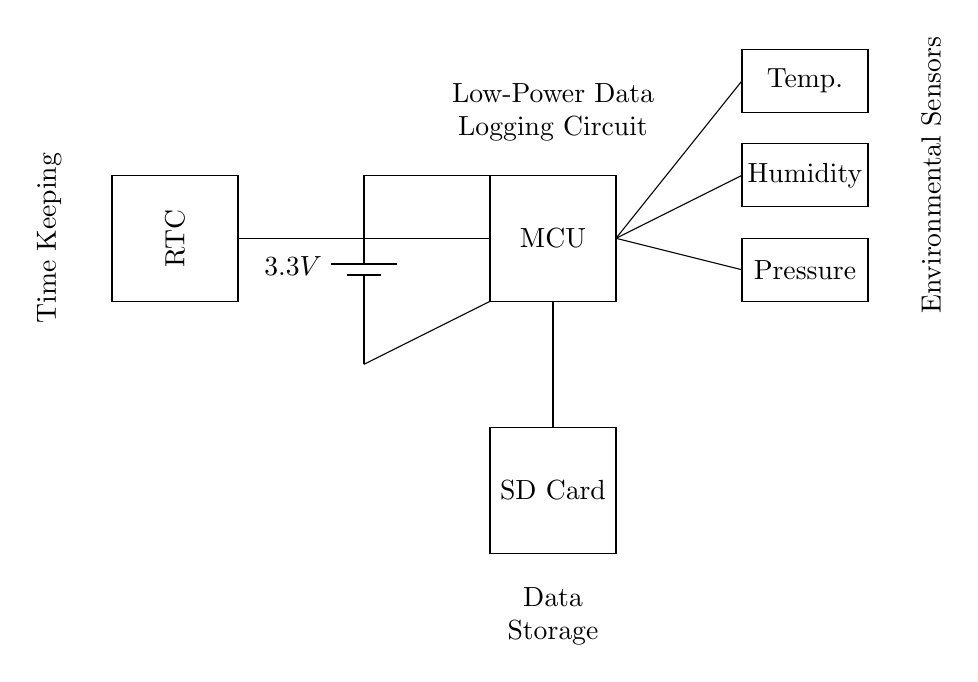What is the voltage of this circuit? The voltage is 3.3 volts, as indicated by the battery labeled with that voltage value in the circuit.
Answer: 3.3 volts What component is used for timekeeping? The Real-Time Clock (RTC) is specifically designated as the timekeeping mechanism in the circuit diagram, which is a common component utilized for logging time in data logging applications.
Answer: RTC How many environmental sensors are present in the circuit? There are three environmental sensors visible in the circuit diagram, identified as temperature, humidity, and pressure sensors, each represented by separate rectangles.
Answer: Three What is the primary purpose of the microcontroller? The microcontroller (MCU) acts as the central processing unit for the circuit, coordinating data collection from the sensors and saving it to the SD card, thus performing essential control and processing functions.
Answer: Control and processing Which component is responsible for data storage? The SD card is clearly illustrated in the circuit as the data storage component, which serves to retain the logged environmental data for future analysis.
Answer: SD Card How are the sensors powered in this circuit? The sensors are powered by the main battery, as indicated by the connections leading from the battery to the microcontroller and subsequently to the sensors, suggesting they draw power from the same source.
Answer: Battery Why is low power consumption essential for this circuit? Low power consumption is crucial for long-term environmental monitoring in remote locations, as it allows for sustained operation without the need for frequent battery replacement, enhancing the system's longevity and reliability in isolated environments.
Answer: Long-term operation 